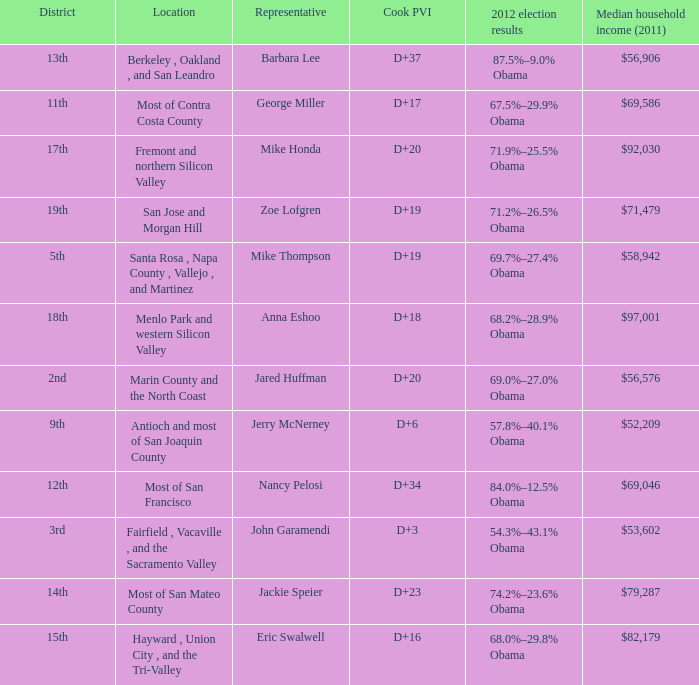How many locations have a median household income in 2011 of $71,479? 1.0. 